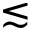Convert formula to latex. <formula><loc_0><loc_0><loc_500><loc_500>\lesssim</formula> 